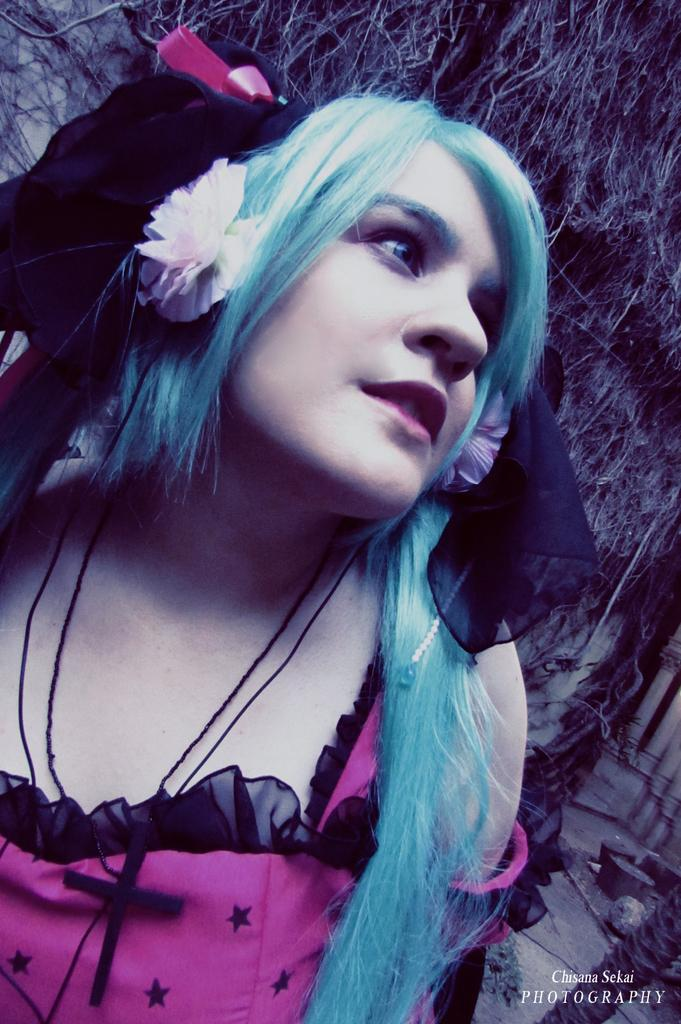Who is present in the image? There is a woman in the image. How many pizzas are hanging on the wall in the image? There is no mention of pizzas or a wall in the image; it only features a woman. 